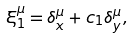Convert formula to latex. <formula><loc_0><loc_0><loc_500><loc_500>\xi _ { 1 } ^ { \mu } = \delta _ { x } ^ { \mu } + c _ { 1 } \delta _ { y } ^ { \mu } ,</formula> 